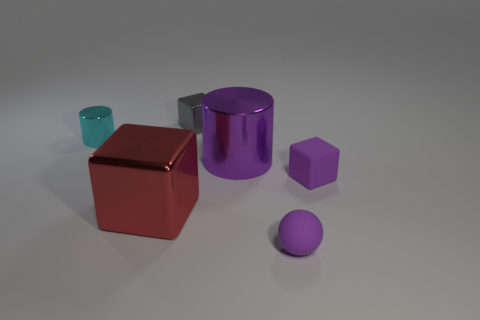Are there any other things of the same color as the tiny rubber sphere?
Your response must be concise. Yes. There is a large block; is its color the same as the big object that is to the right of the big metal cube?
Keep it short and to the point. No. Is the number of rubber balls that are on the left side of the gray cube less than the number of large red shiny things?
Give a very brief answer. Yes. There is a thing that is on the left side of the big block; what is it made of?
Give a very brief answer. Metal. What number of other objects are there of the same size as the gray object?
Keep it short and to the point. 3. There is a red shiny object; does it have the same size as the matte object in front of the small rubber cube?
Give a very brief answer. No. What shape is the rubber thing to the right of the tiny purple object that is in front of the metallic block that is in front of the gray cube?
Ensure brevity in your answer.  Cube. Are there fewer large red objects than blocks?
Provide a succinct answer. Yes. There is a small metallic block; are there any purple blocks behind it?
Provide a short and direct response. No. There is a tiny object that is behind the big red shiny object and in front of the small cyan metal cylinder; what shape is it?
Offer a terse response. Cube. 